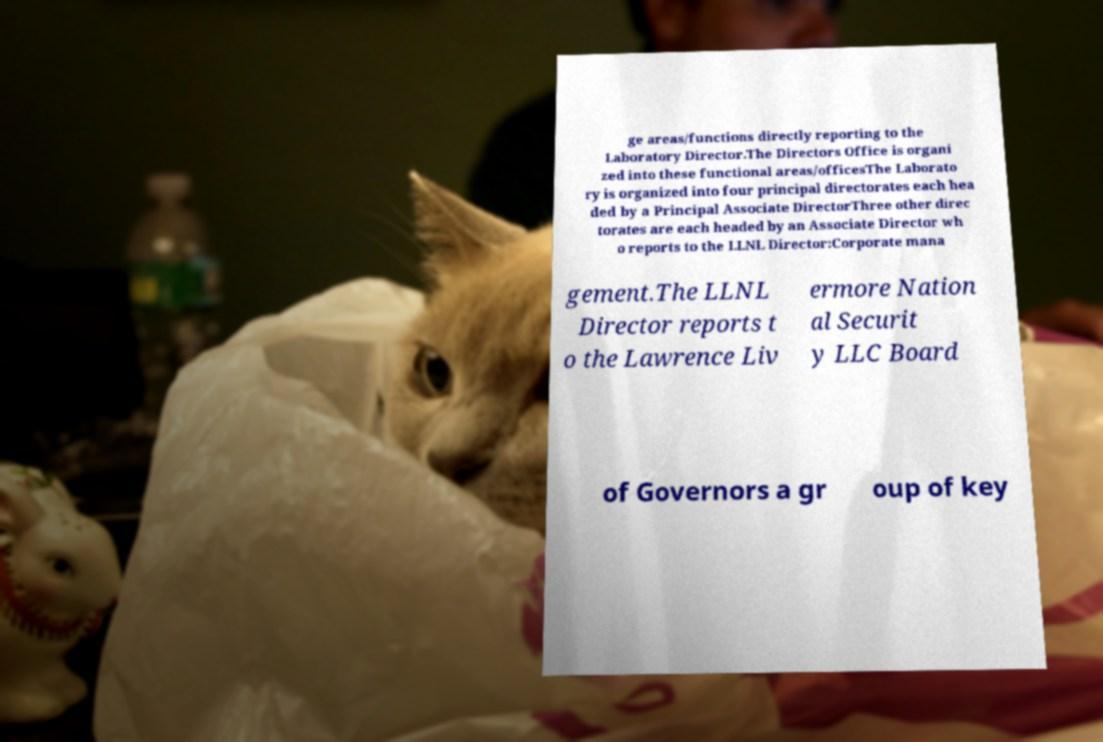What messages or text are displayed in this image? I need them in a readable, typed format. ge areas/functions directly reporting to the Laboratory Director.The Directors Office is organi zed into these functional areas/officesThe Laborato ry is organized into four principal directorates each hea ded by a Principal Associate DirectorThree other direc torates are each headed by an Associate Director wh o reports to the LLNL Director:Corporate mana gement.The LLNL Director reports t o the Lawrence Liv ermore Nation al Securit y LLC Board of Governors a gr oup of key 